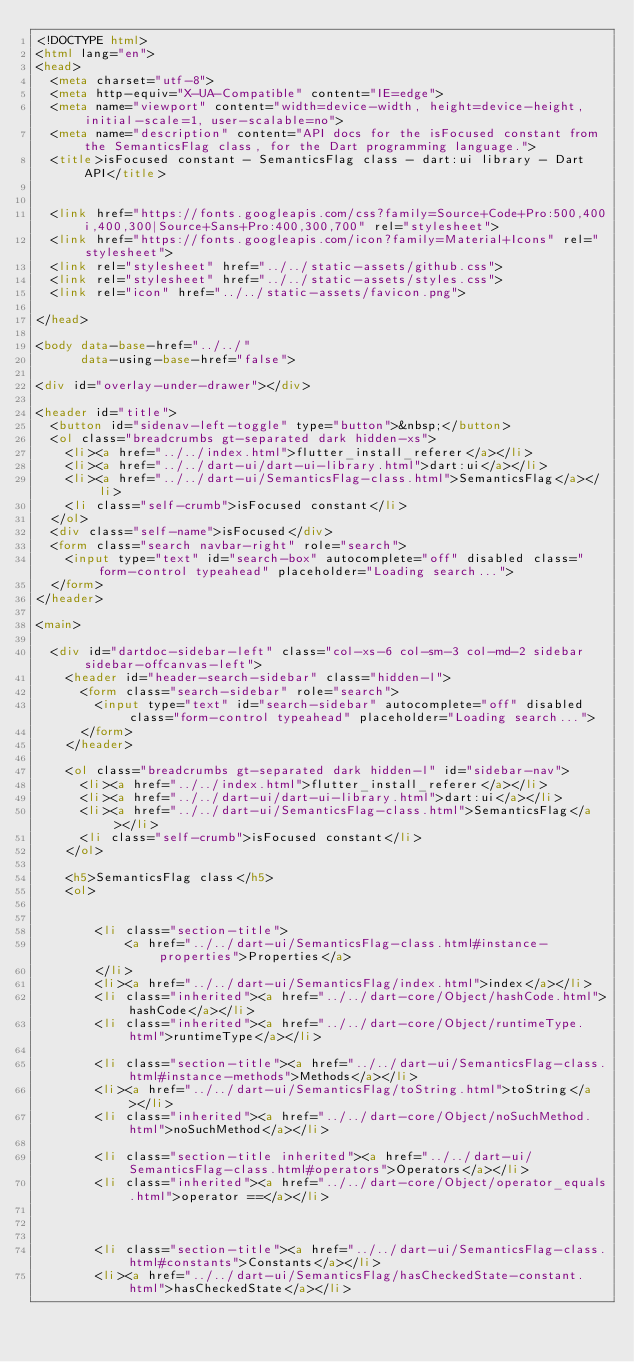<code> <loc_0><loc_0><loc_500><loc_500><_HTML_><!DOCTYPE html>
<html lang="en">
<head>
  <meta charset="utf-8">
  <meta http-equiv="X-UA-Compatible" content="IE=edge">
  <meta name="viewport" content="width=device-width, height=device-height, initial-scale=1, user-scalable=no">
  <meta name="description" content="API docs for the isFocused constant from the SemanticsFlag class, for the Dart programming language.">
  <title>isFocused constant - SemanticsFlag class - dart:ui library - Dart API</title>

  
  <link href="https://fonts.googleapis.com/css?family=Source+Code+Pro:500,400i,400,300|Source+Sans+Pro:400,300,700" rel="stylesheet">
  <link href="https://fonts.googleapis.com/icon?family=Material+Icons" rel="stylesheet">
  <link rel="stylesheet" href="../../static-assets/github.css">
  <link rel="stylesheet" href="../../static-assets/styles.css">
  <link rel="icon" href="../../static-assets/favicon.png">

</head>

<body data-base-href="../../"
      data-using-base-href="false">

<div id="overlay-under-drawer"></div>

<header id="title">
  <button id="sidenav-left-toggle" type="button">&nbsp;</button>
  <ol class="breadcrumbs gt-separated dark hidden-xs">
    <li><a href="../../index.html">flutter_install_referer</a></li>
    <li><a href="../../dart-ui/dart-ui-library.html">dart:ui</a></li>
    <li><a href="../../dart-ui/SemanticsFlag-class.html">SemanticsFlag</a></li>
    <li class="self-crumb">isFocused constant</li>
  </ol>
  <div class="self-name">isFocused</div>
  <form class="search navbar-right" role="search">
    <input type="text" id="search-box" autocomplete="off" disabled class="form-control typeahead" placeholder="Loading search...">
  </form>
</header>

<main>

  <div id="dartdoc-sidebar-left" class="col-xs-6 col-sm-3 col-md-2 sidebar sidebar-offcanvas-left">
    <header id="header-search-sidebar" class="hidden-l">
      <form class="search-sidebar" role="search">
        <input type="text" id="search-sidebar" autocomplete="off" disabled class="form-control typeahead" placeholder="Loading search...">
      </form>
    </header>
    
    <ol class="breadcrumbs gt-separated dark hidden-l" id="sidebar-nav">
      <li><a href="../../index.html">flutter_install_referer</a></li>
      <li><a href="../../dart-ui/dart-ui-library.html">dart:ui</a></li>
      <li><a href="../../dart-ui/SemanticsFlag-class.html">SemanticsFlag</a></li>
      <li class="self-crumb">isFocused constant</li>
    </ol>
    
    <h5>SemanticsFlag class</h5>
    <ol>
    
    
        <li class="section-title">
            <a href="../../dart-ui/SemanticsFlag-class.html#instance-properties">Properties</a>
        </li>
        <li><a href="../../dart-ui/SemanticsFlag/index.html">index</a></li>
        <li class="inherited"><a href="../../dart-core/Object/hashCode.html">hashCode</a></li>
        <li class="inherited"><a href="../../dart-core/Object/runtimeType.html">runtimeType</a></li>
    
        <li class="section-title"><a href="../../dart-ui/SemanticsFlag-class.html#instance-methods">Methods</a></li>
        <li><a href="../../dart-ui/SemanticsFlag/toString.html">toString</a></li>
        <li class="inherited"><a href="../../dart-core/Object/noSuchMethod.html">noSuchMethod</a></li>
    
        <li class="section-title inherited"><a href="../../dart-ui/SemanticsFlag-class.html#operators">Operators</a></li>
        <li class="inherited"><a href="../../dart-core/Object/operator_equals.html">operator ==</a></li>
    
    
    
        <li class="section-title"><a href="../../dart-ui/SemanticsFlag-class.html#constants">Constants</a></li>
        <li><a href="../../dart-ui/SemanticsFlag/hasCheckedState-constant.html">hasCheckedState</a></li></code> 